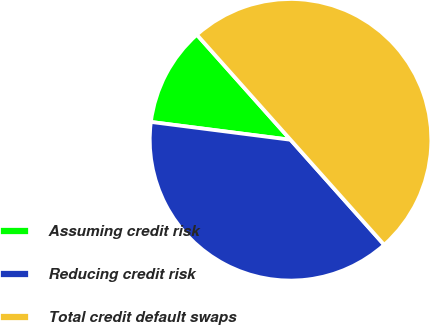Convert chart. <chart><loc_0><loc_0><loc_500><loc_500><pie_chart><fcel>Assuming credit risk<fcel>Reducing credit risk<fcel>Total credit default swaps<nl><fcel>11.39%<fcel>38.61%<fcel>50.0%<nl></chart> 